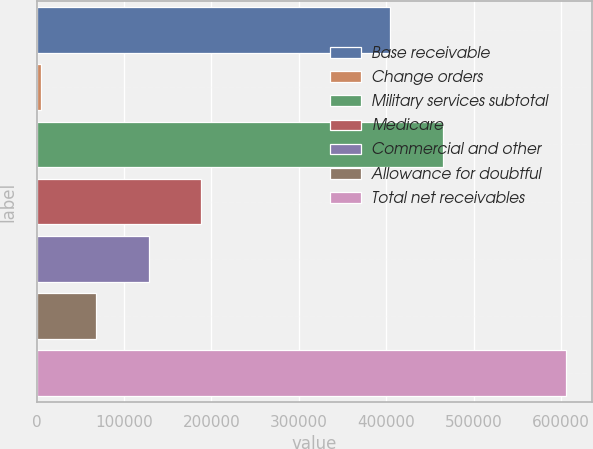<chart> <loc_0><loc_0><loc_500><loc_500><bar_chart><fcel>Base receivable<fcel>Change orders<fcel>Military services subtotal<fcel>Medicare<fcel>Commercial and other<fcel>Allowance for doubtful<fcel>Total net receivables<nl><fcel>404570<fcel>5168<fcel>464607<fcel>188335<fcel>128297<fcel>68260<fcel>605541<nl></chart> 